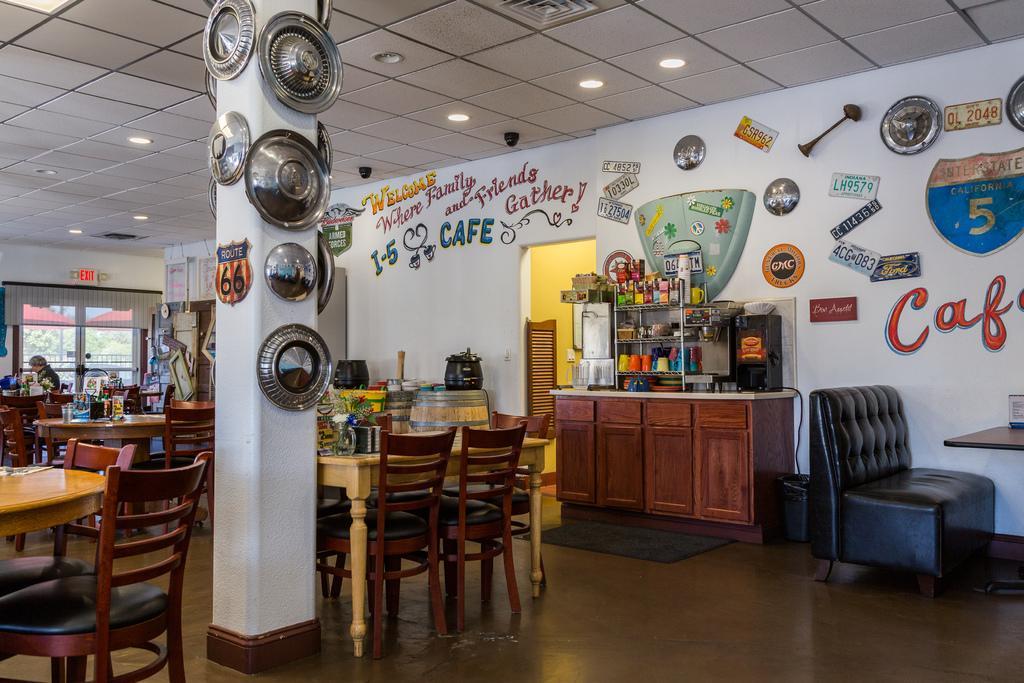How would you summarize this image in a sentence or two? In this image i can see a pillar few plates attached to the pillar, at the background i can see a dining table on a cup board i can see few glasses and bottles at the back ground i can see a wall on the top i can a light. 